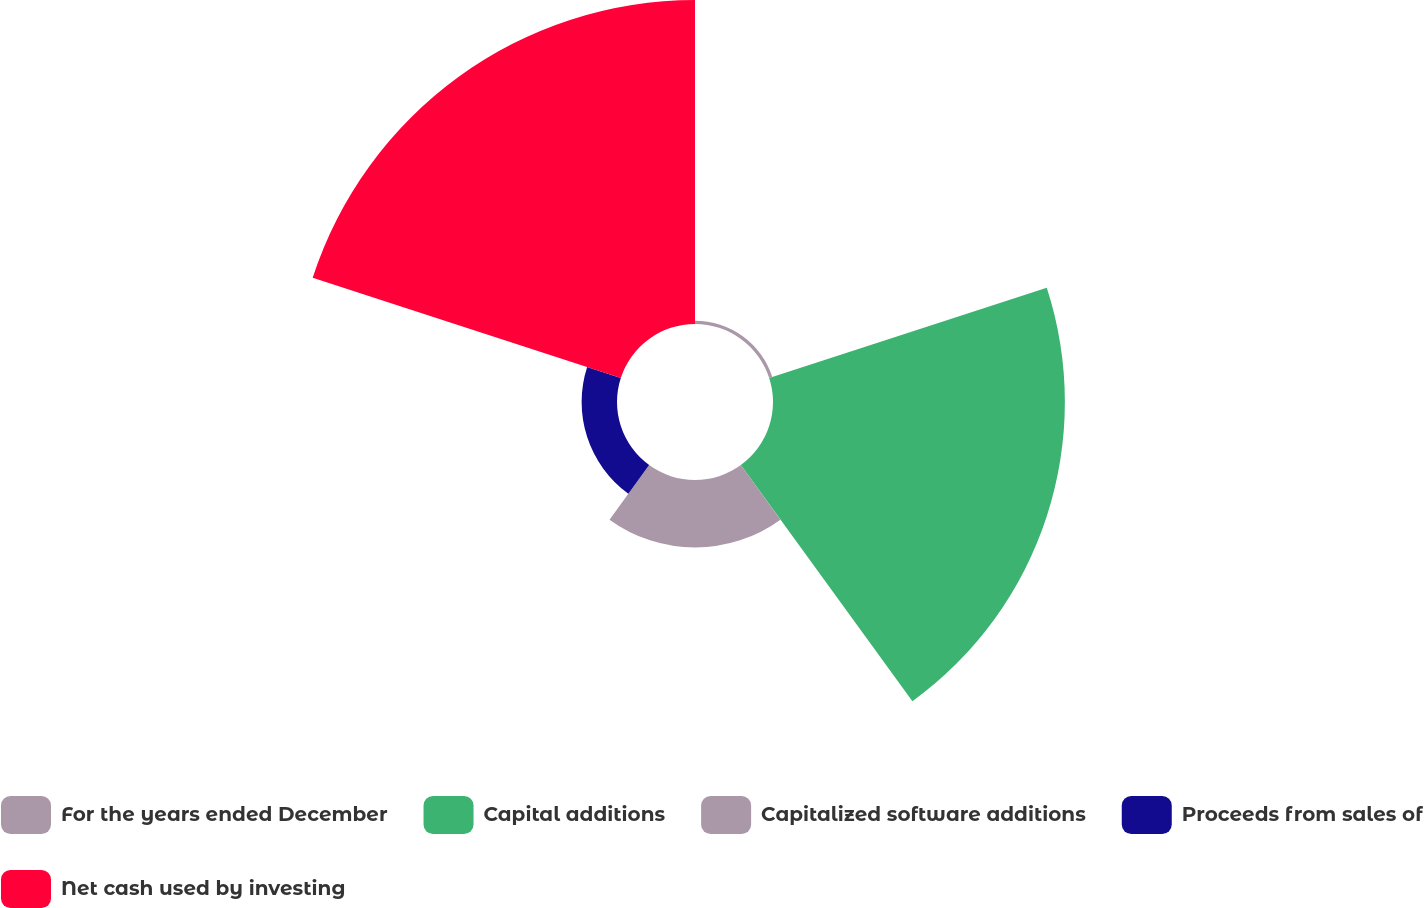<chart> <loc_0><loc_0><loc_500><loc_500><pie_chart><fcel>For the years ended December<fcel>Capital additions<fcel>Capitalized software additions<fcel>Proceeds from sales of<fcel>Net cash used by investing<nl><fcel>0.45%<fcel>40.43%<fcel>9.34%<fcel>4.9%<fcel>44.88%<nl></chart> 